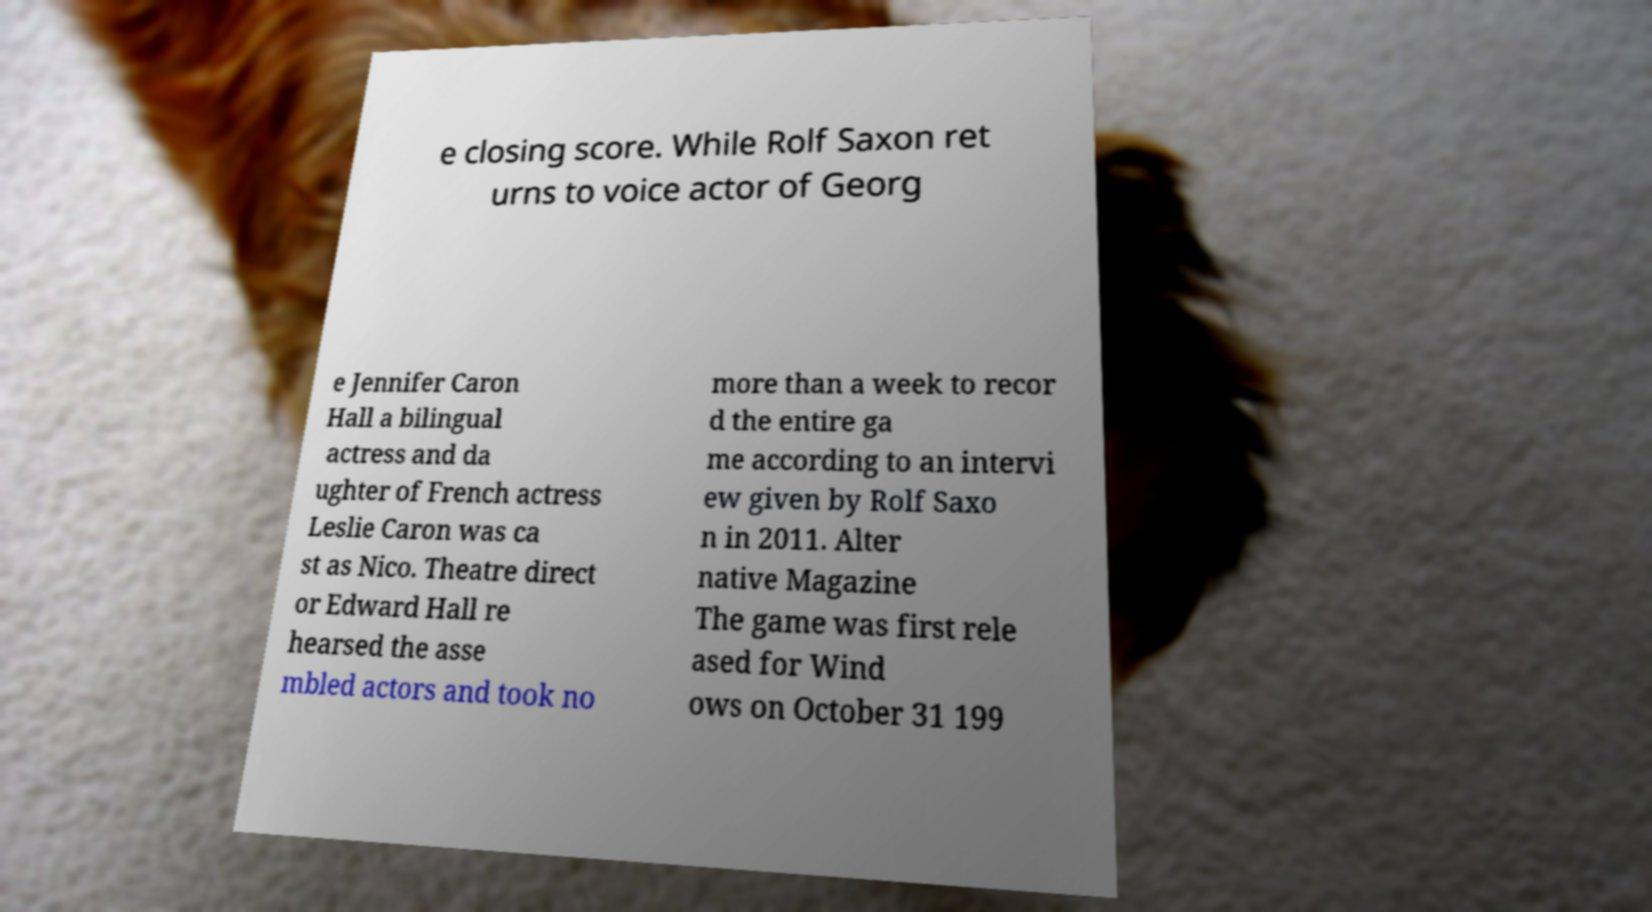Could you assist in decoding the text presented in this image and type it out clearly? e closing score. While Rolf Saxon ret urns to voice actor of Georg e Jennifer Caron Hall a bilingual actress and da ughter of French actress Leslie Caron was ca st as Nico. Theatre direct or Edward Hall re hearsed the asse mbled actors and took no more than a week to recor d the entire ga me according to an intervi ew given by Rolf Saxo n in 2011. Alter native Magazine The game was first rele ased for Wind ows on October 31 199 